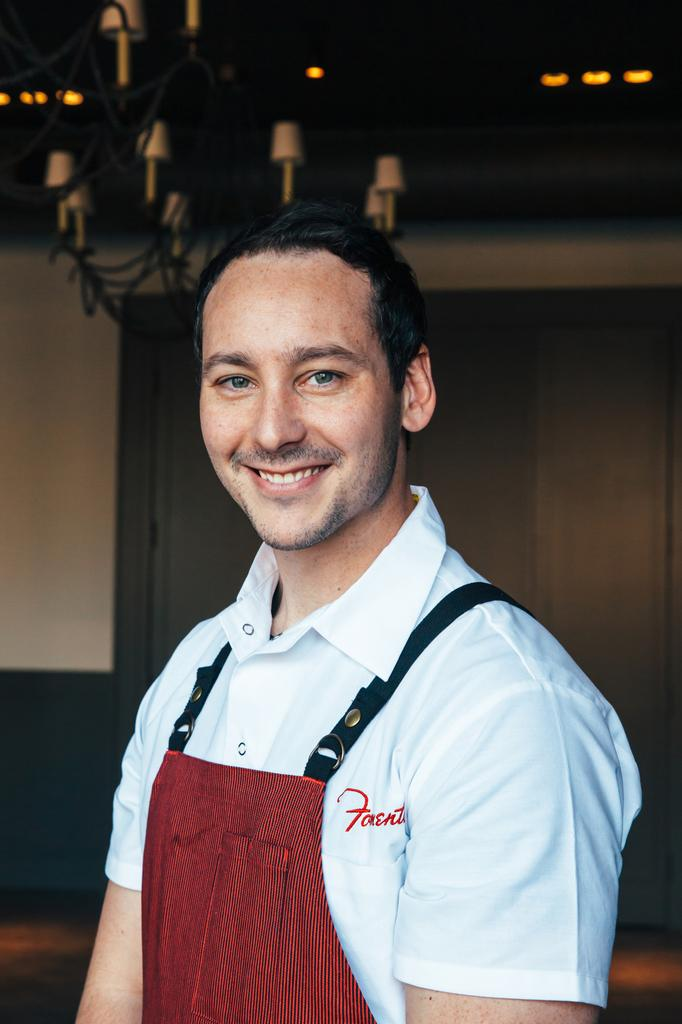<image>
Create a compact narrative representing the image presented. A man wearing a white polo with red lettering that says Foent. 